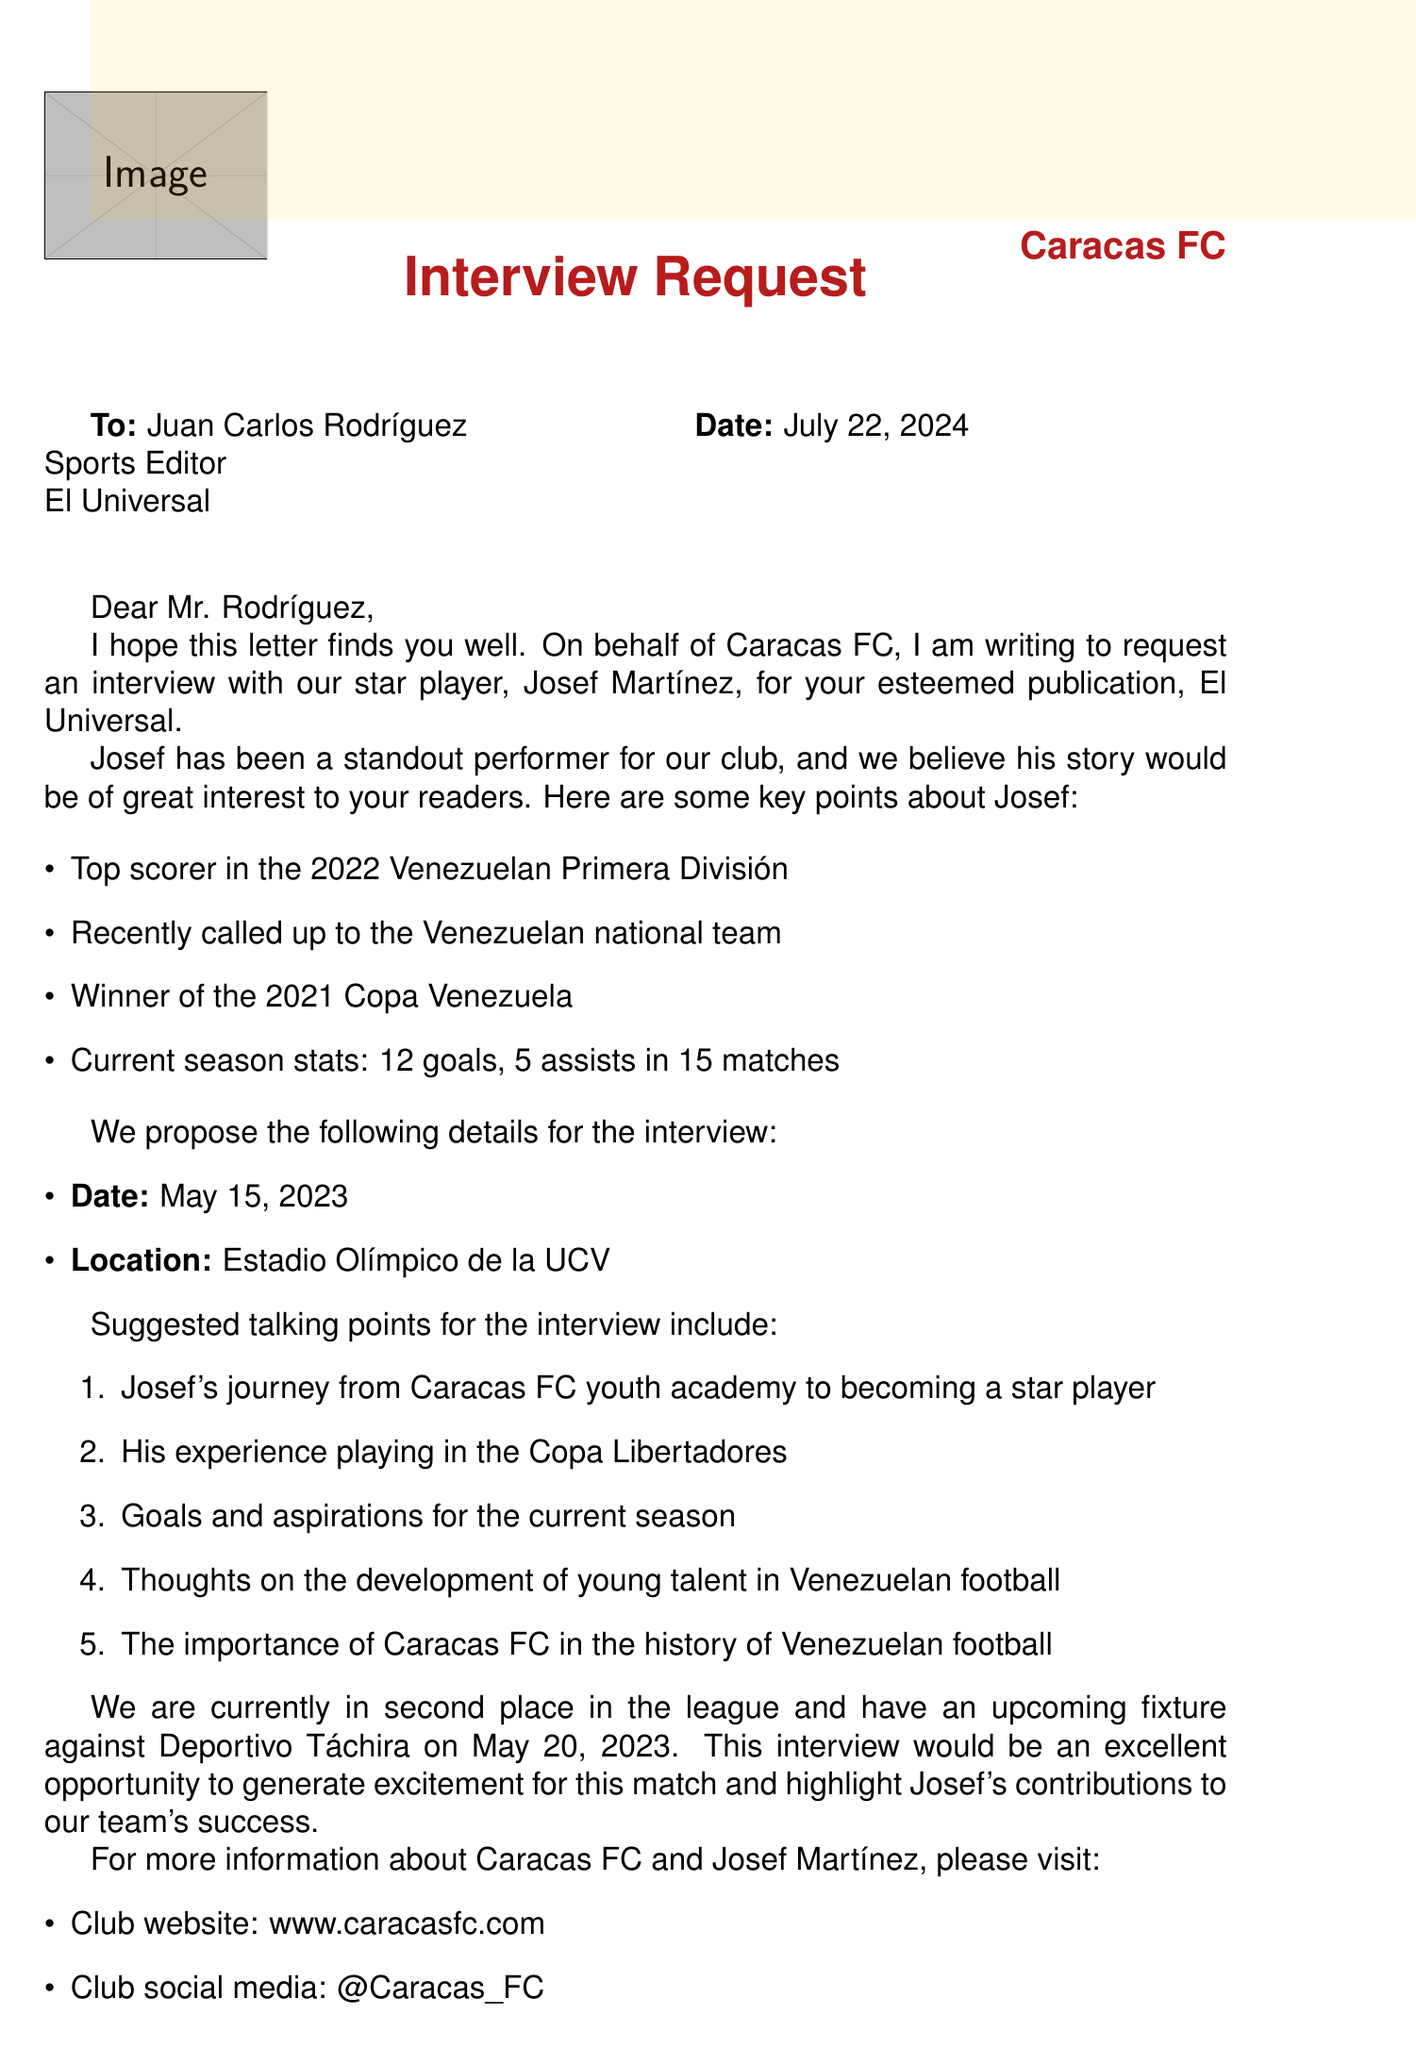What is the name of the player requested for the interview? The name of the player is mentioned in the request, which is Josef Martínez.
Answer: Josef Martínez Who is the recipient of the interview request letter? The letter addresses Juan Carlos Rodríguez, who is identified as the Sports Editor.
Answer: Juan Carlos Rodríguez What date is the proposed interview scheduled for? The proposed date for the interview is specified in the request.
Answer: May 15, 2023 How many goals has Josef Martínez scored in the current season? The document provides specific current season stats, indicating 12 goals scored by Josef Martínez.
Answer: 12 What is the current league position of Caracas FC? The document states that Caracas FC is in second place in the league.
Answer: 2 What is one of the talking points suggested for the interview? The document lists several talking points, one of them being Josef's experience playing in the Copa Libertadores.
Answer: His experience playing in the Copa Libertadores When is Caracas FC's upcoming fixture? The document mentions the date of the upcoming fixture against Deportivo Táchira.
Answer: May 20, 2023 Who is the contact person for the PR team? The PR team contact is specified in the document.
Answer: María Alejandra Pérez What is the social media handle for Caracas FC? The document contains the social media handle for Caracas FC.
Answer: @Caracas_FC What was Josef Martínez's achievement in the 2022 Venezuelan Primera División? The letter mentions that Josef was the top scorer in that season.
Answer: Top scorer in the 2022 Venezuelan Primera División 